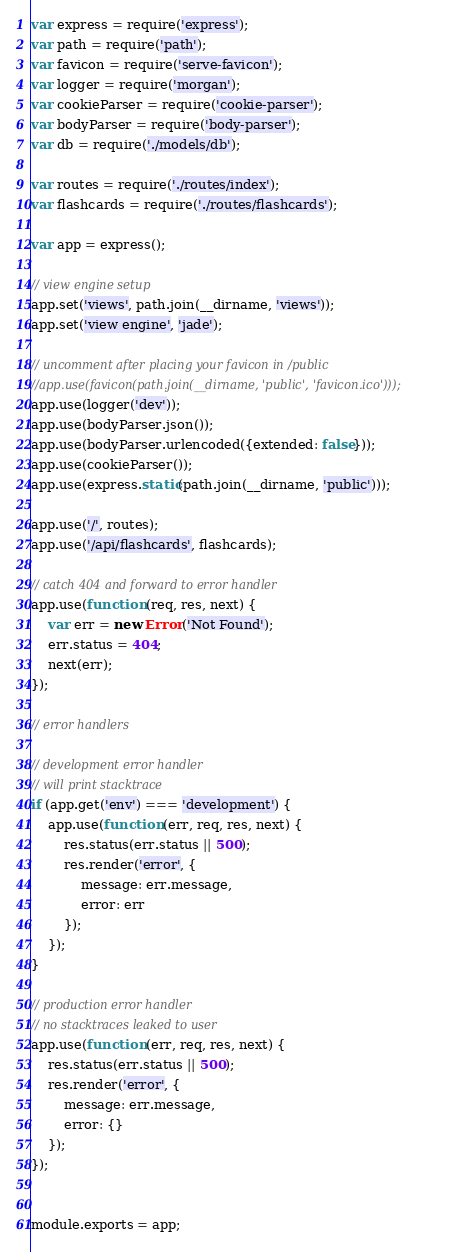Convert code to text. <code><loc_0><loc_0><loc_500><loc_500><_JavaScript_>var express = require('express');
var path = require('path');
var favicon = require('serve-favicon');
var logger = require('morgan');
var cookieParser = require('cookie-parser');
var bodyParser = require('body-parser');
var db = require('./models/db');

var routes = require('./routes/index');
var flashcards = require('./routes/flashcards');

var app = express();

// view engine setup
app.set('views', path.join(__dirname, 'views'));
app.set('view engine', 'jade');

// uncomment after placing your favicon in /public
//app.use(favicon(path.join(__dirname, 'public', 'favicon.ico')));
app.use(logger('dev'));
app.use(bodyParser.json());
app.use(bodyParser.urlencoded({extended: false}));
app.use(cookieParser());
app.use(express.static(path.join(__dirname, 'public')));

app.use('/', routes);
app.use('/api/flashcards', flashcards);

// catch 404 and forward to error handler
app.use(function (req, res, next) {
    var err = new Error('Not Found');
    err.status = 404;
    next(err);
});

// error handlers

// development error handler
// will print stacktrace
if (app.get('env') === 'development') {
    app.use(function (err, req, res, next) {
        res.status(err.status || 500);
        res.render('error', {
            message: err.message,
            error: err
        });
    });
}

// production error handler
// no stacktraces leaked to user
app.use(function (err, req, res, next) {
    res.status(err.status || 500);
    res.render('error', {
        message: err.message,
        error: {}
    });
});


module.exports = app;
</code> 